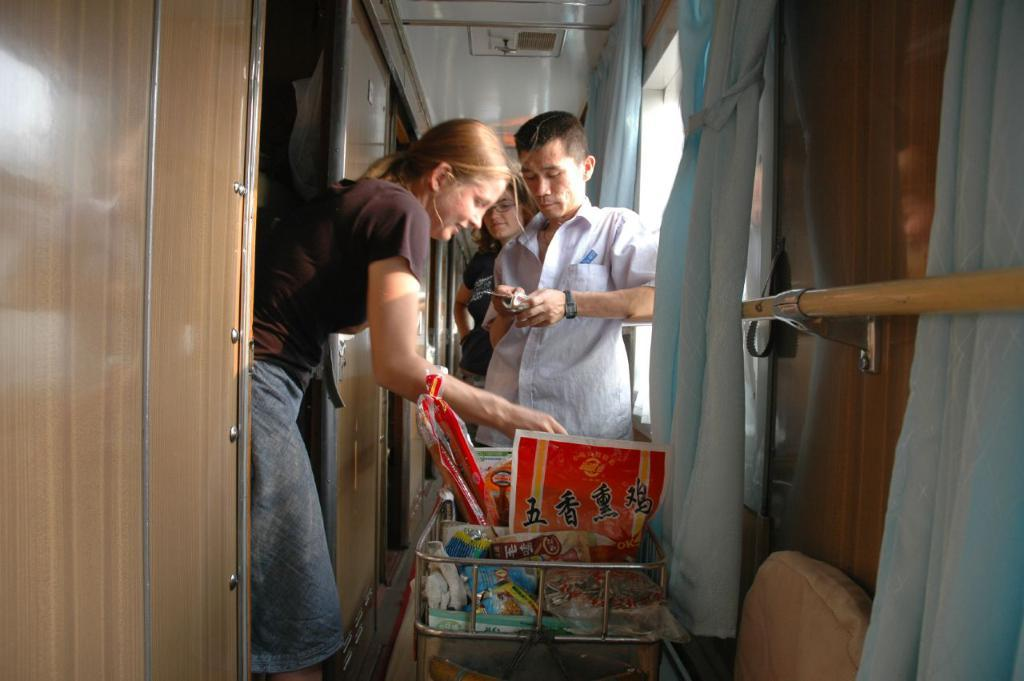What are the people in the image doing? There are people standing in the image. Can you describe what the man is holding? The man is holding a cellphone. What is the woman holding in the image? The woman is holding a trolley. What type of window treatment is visible in the image? There are windows with curtains in the image. What architectural features can be seen in the image? There is a wall, a door, and a roof in the image. What type of stove can be seen in the image? There is no stove present in the image. How many cakes are visible on the trolley in the image? There is no trolley with cakes in the image; the woman is holding a trolley with unspecified items. 